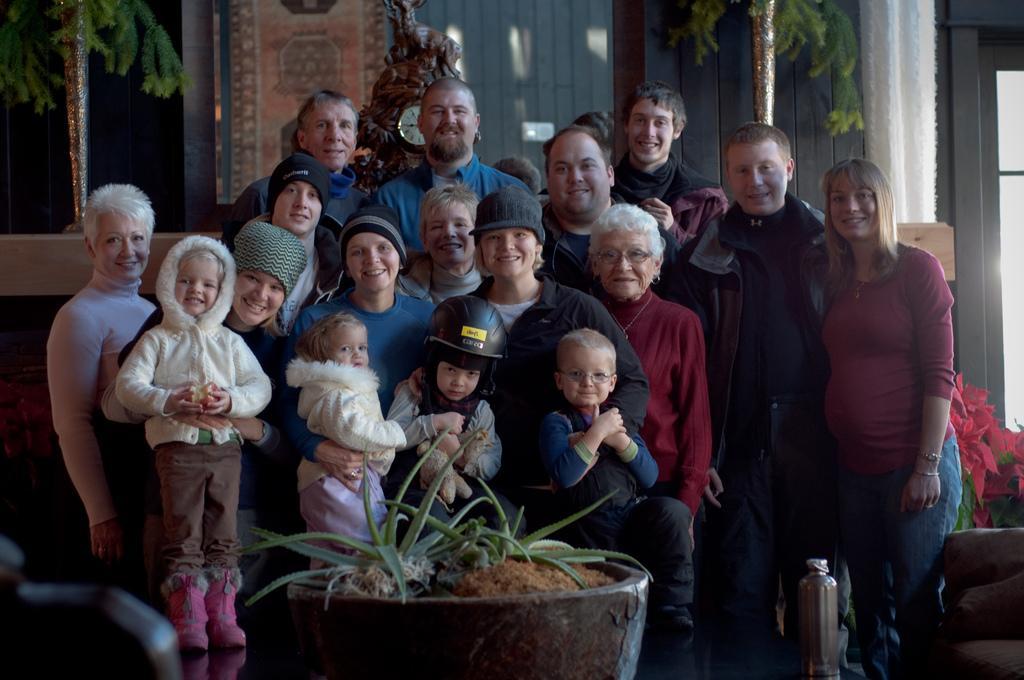In one or two sentences, can you explain what this image depicts? In this image we can see a group of persons. In front of the persons we can see a houseplant. Behind the persons we can see a wall clock, a wall and plants. On the right side, we can see a glass door and a plant. 